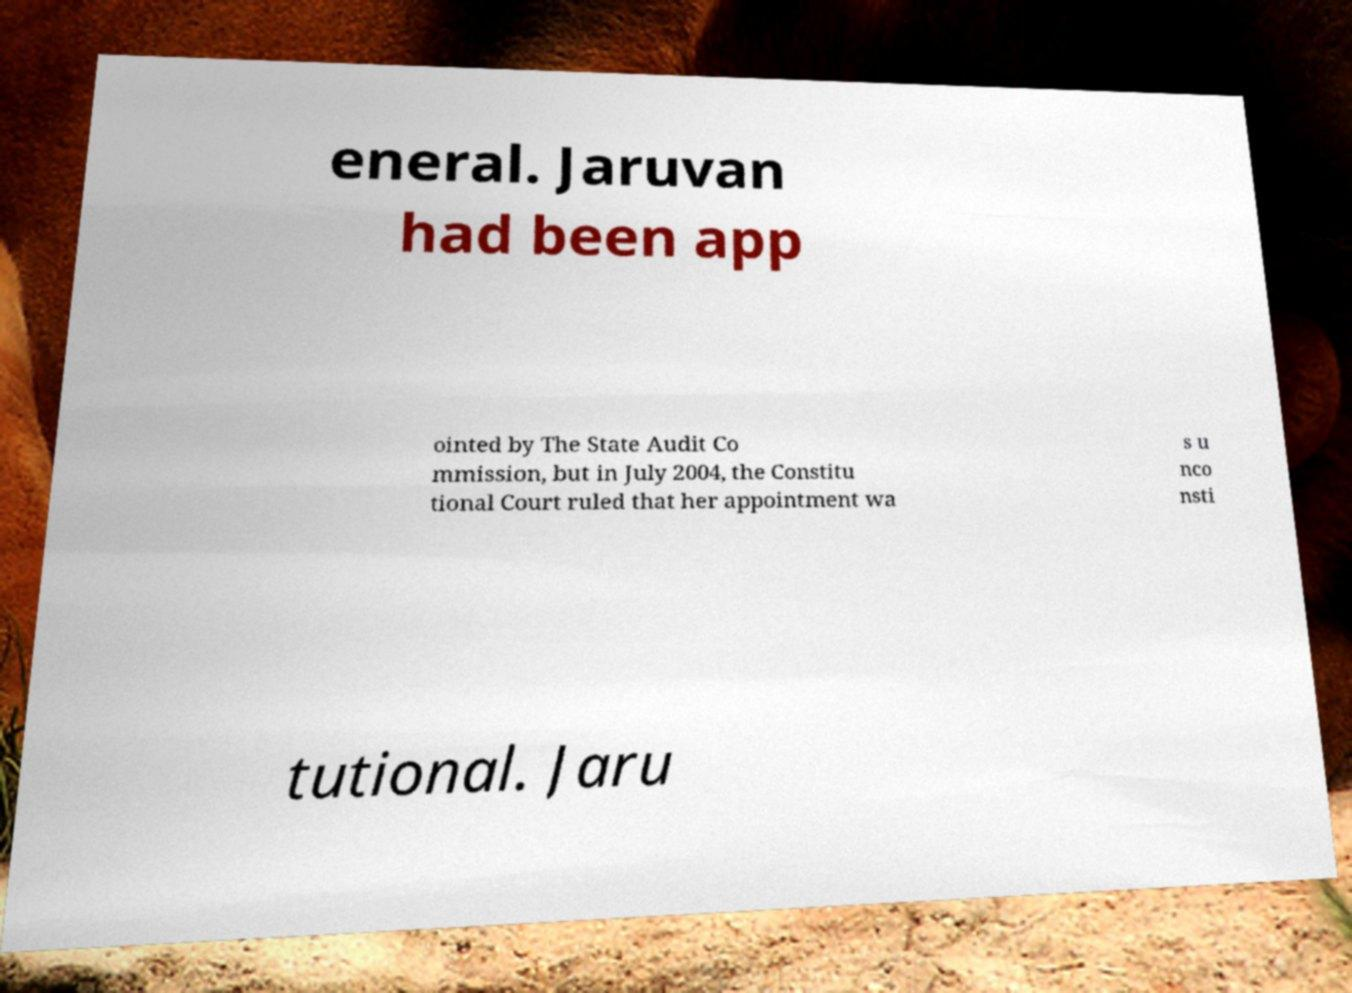I need the written content from this picture converted into text. Can you do that? eneral. Jaruvan had been app ointed by The State Audit Co mmission, but in July 2004, the Constitu tional Court ruled that her appointment wa s u nco nsti tutional. Jaru 